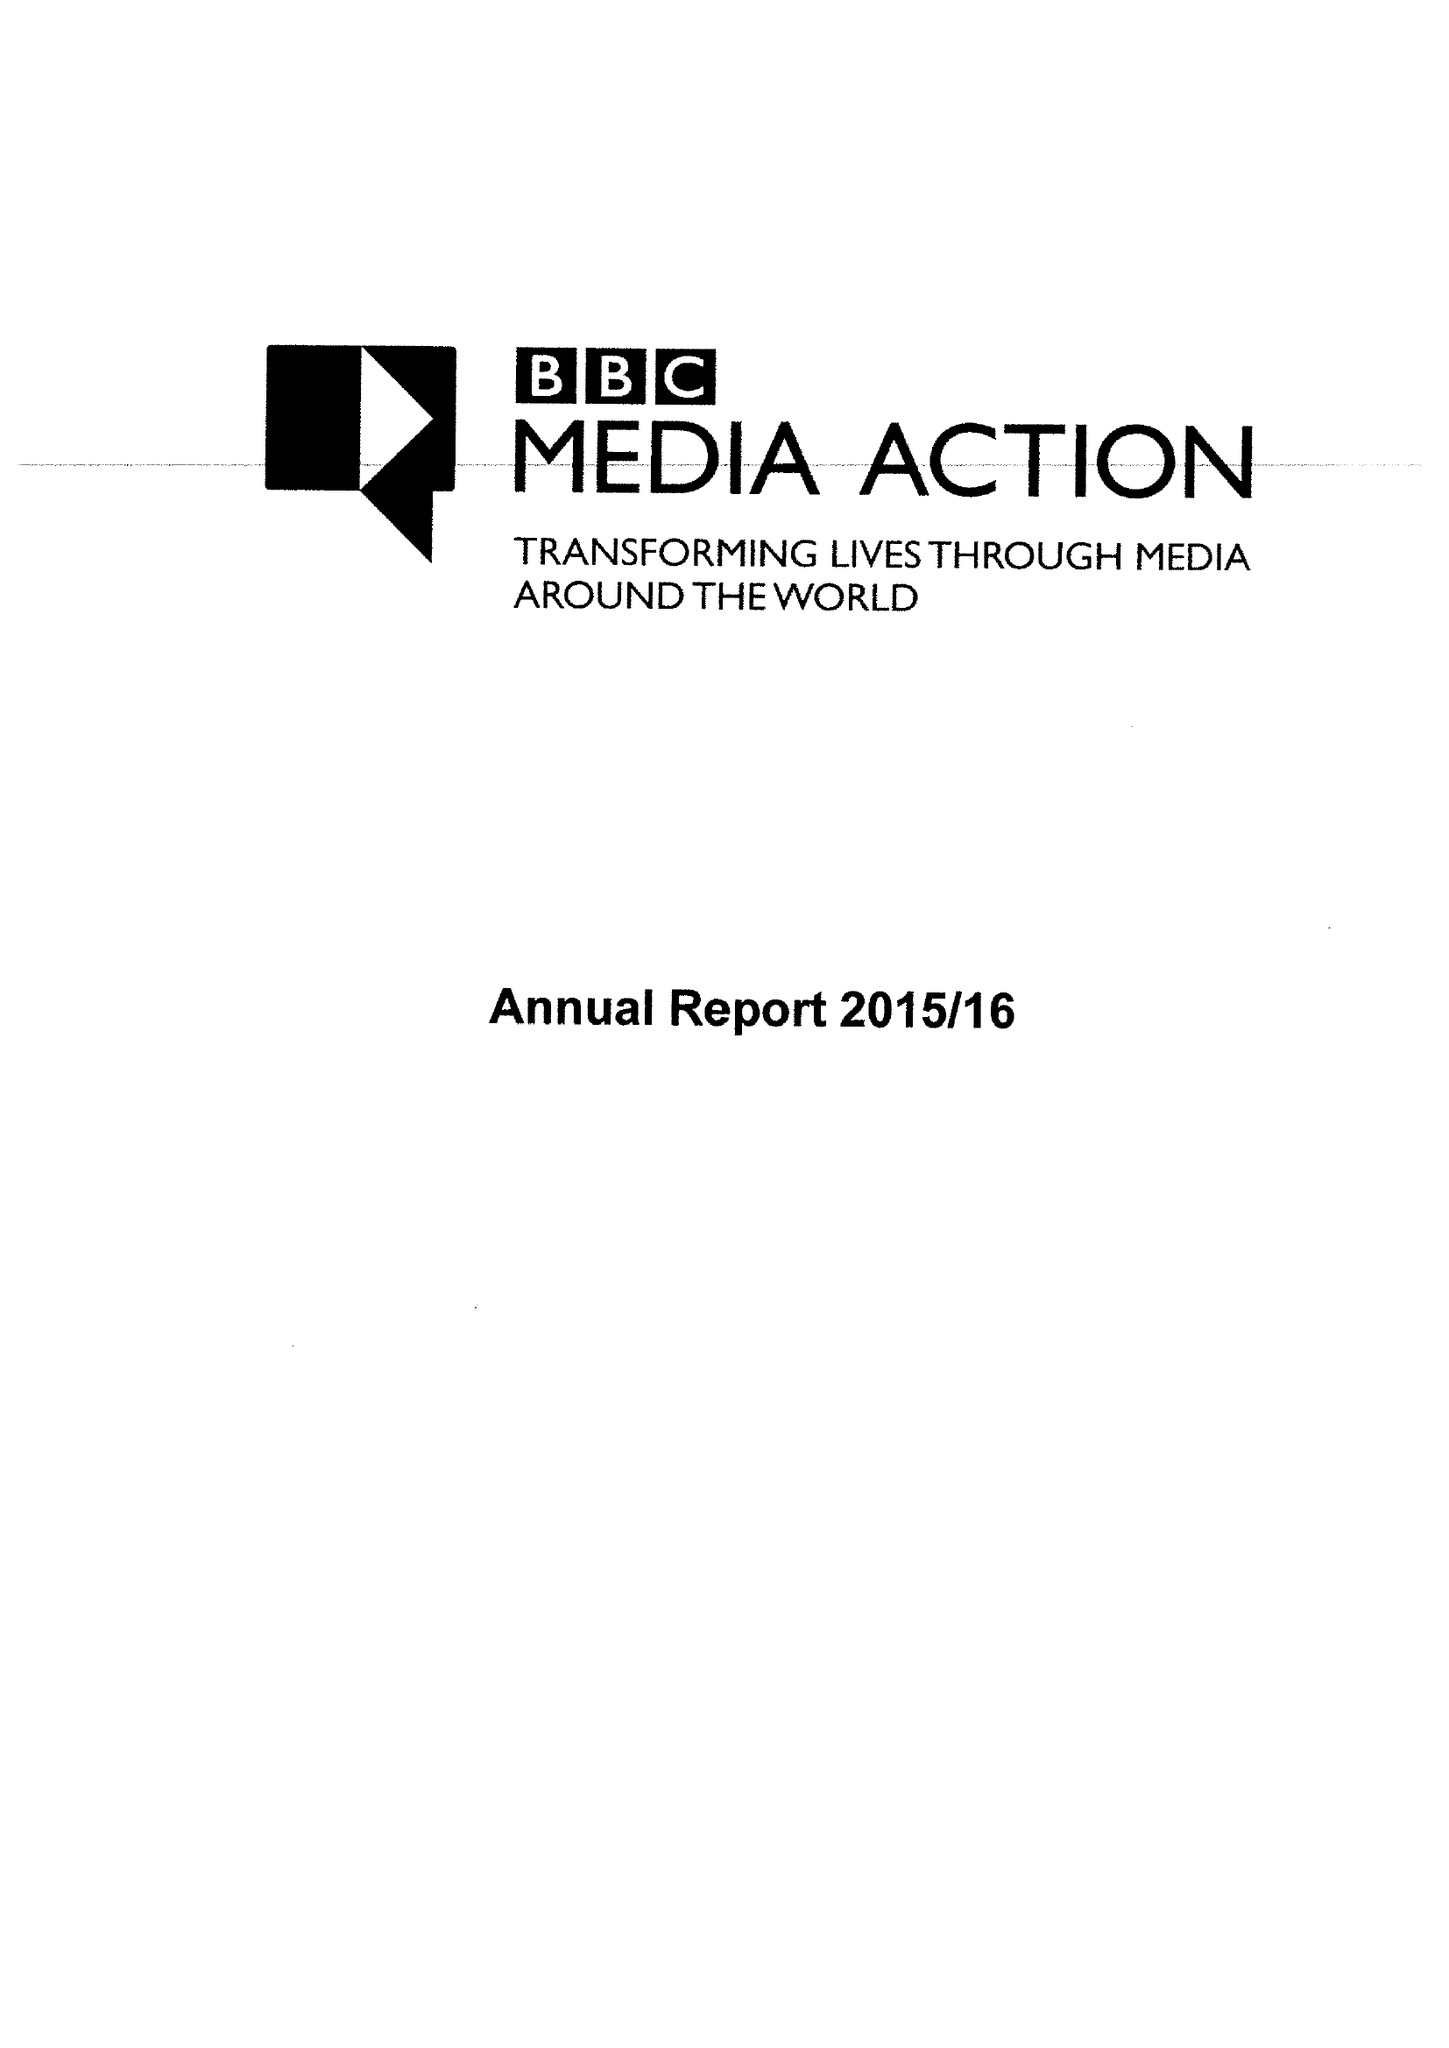What is the value for the charity_number?
Answer the question using a single word or phrase. 1076235 